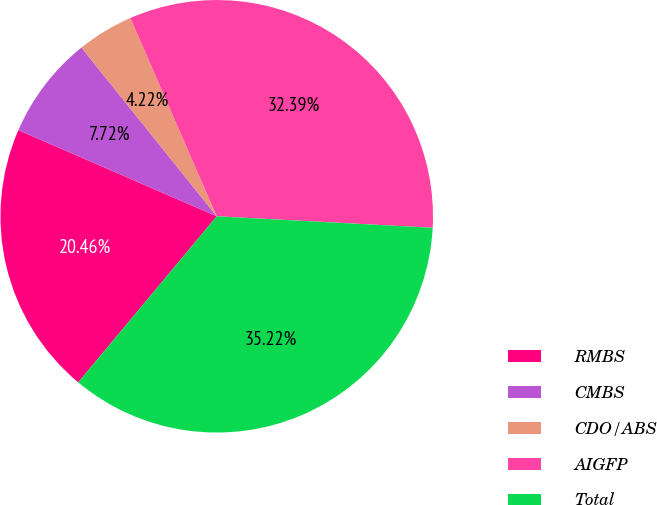Convert chart. <chart><loc_0><loc_0><loc_500><loc_500><pie_chart><fcel>RMBS<fcel>CMBS<fcel>CDO/ABS<fcel>AIGFP<fcel>Total<nl><fcel>20.46%<fcel>7.72%<fcel>4.22%<fcel>32.39%<fcel>35.22%<nl></chart> 